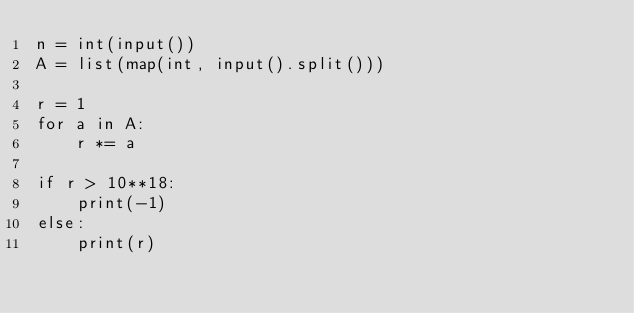<code> <loc_0><loc_0><loc_500><loc_500><_Python_>n = int(input())
A = list(map(int, input().split()))

r = 1
for a in A:
    r *= a

if r > 10**18:
    print(-1)
else:
    print(r)</code> 